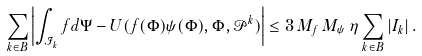<formula> <loc_0><loc_0><loc_500><loc_500>\sum _ { k \in B } \left | \int _ { \mathcal { I } _ { k } } f d \Psi - U ( f ( \Phi ) \psi ( \Phi ) , \Phi , \mathcal { P } ^ { k } ) \right | \leq 3 \, M _ { f } \, M _ { \psi } \, \eta \sum _ { k \in B } | I _ { k } | \, .</formula> 